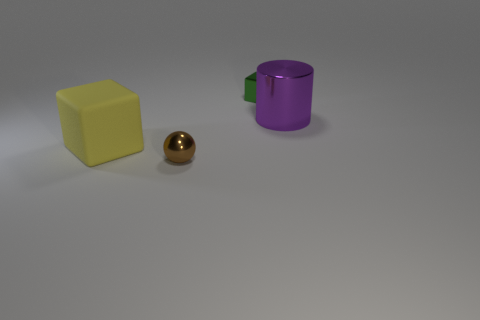Add 1 gray matte spheres. How many objects exist? 5 Subtract all yellow blocks. How many blocks are left? 1 Subtract 0 blue balls. How many objects are left? 4 Subtract all cylinders. How many objects are left? 3 Subtract 1 spheres. How many spheres are left? 0 Subtract all brown cylinders. Subtract all blue balls. How many cylinders are left? 1 Subtract all brown spheres. How many yellow cubes are left? 1 Subtract all large red matte cubes. Subtract all large purple shiny cylinders. How many objects are left? 3 Add 2 small shiny blocks. How many small shiny blocks are left? 3 Add 4 large metallic things. How many large metallic things exist? 5 